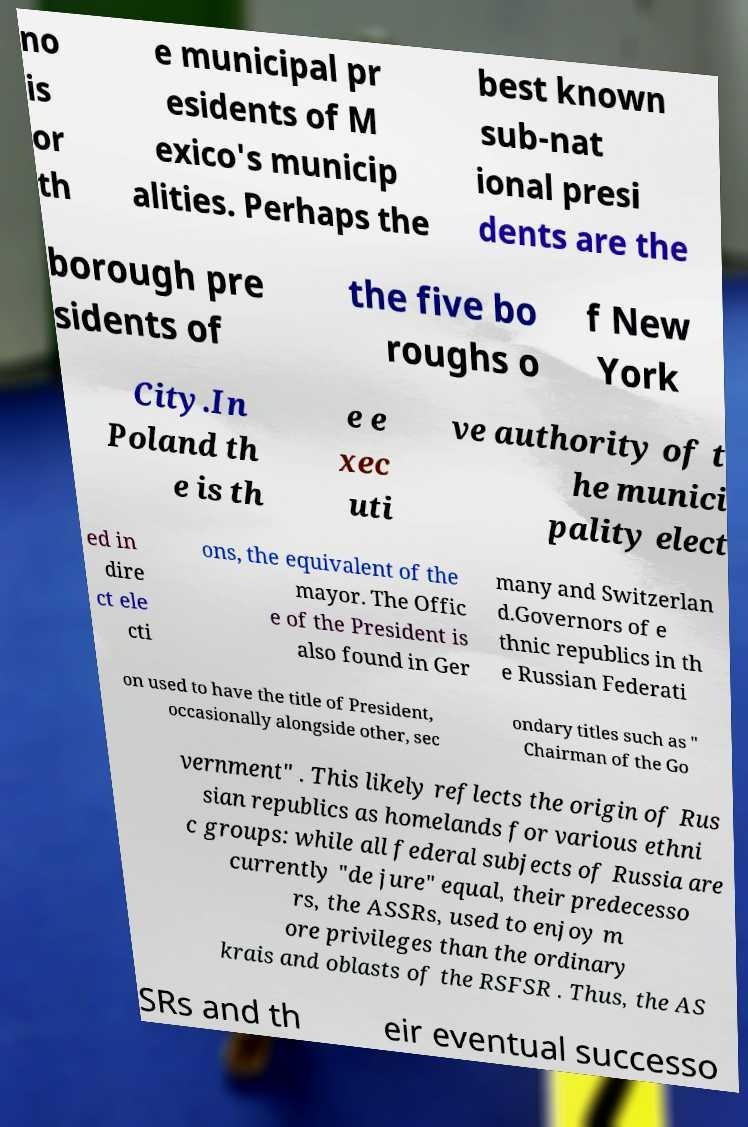Can you accurately transcribe the text from the provided image for me? no is or th e municipal pr esidents of M exico's municip alities. Perhaps the best known sub-nat ional presi dents are the borough pre sidents of the five bo roughs o f New York City.In Poland th e is th e e xec uti ve authority of t he munici pality elect ed in dire ct ele cti ons, the equivalent of the mayor. The Offic e of the President is also found in Ger many and Switzerlan d.Governors of e thnic republics in th e Russian Federati on used to have the title of President, occasionally alongside other, sec ondary titles such as " Chairman of the Go vernment" . This likely reflects the origin of Rus sian republics as homelands for various ethni c groups: while all federal subjects of Russia are currently "de jure" equal, their predecesso rs, the ASSRs, used to enjoy m ore privileges than the ordinary krais and oblasts of the RSFSR . Thus, the AS SRs and th eir eventual successo 